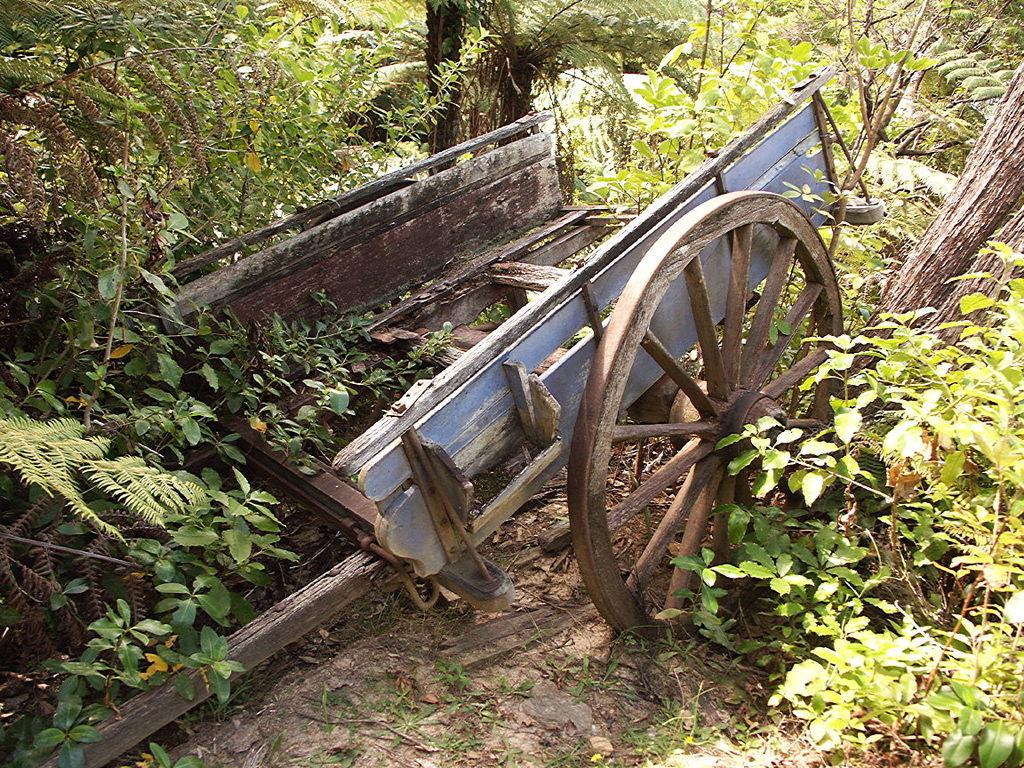What is the condition of the cart in the image? The cart in the image is damaged. What type of vegetation can be seen in the image? There are trees and plants in the image. What type of animal is making a statement in the image? There is no animal present in the image, and therefore no statement can be attributed to an animal. 